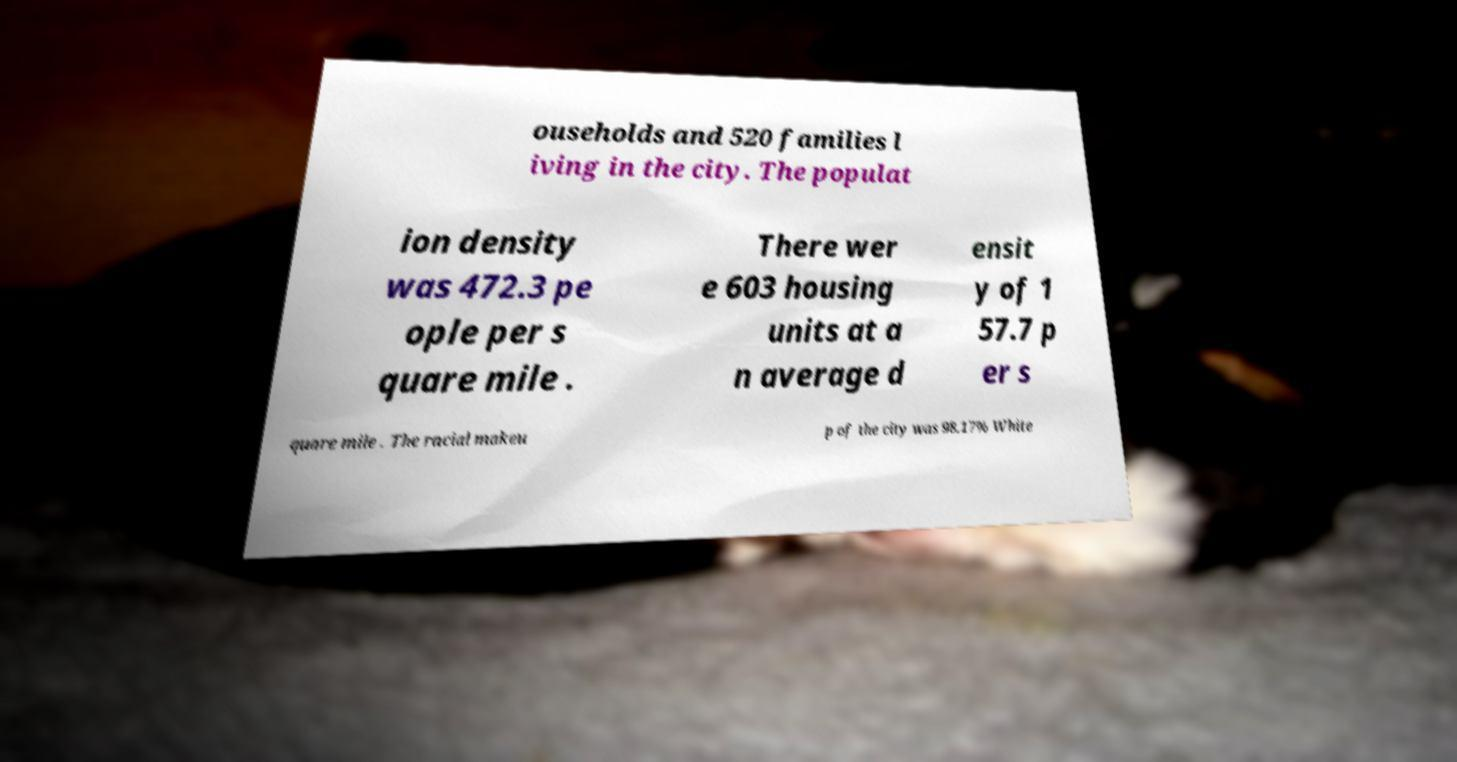There's text embedded in this image that I need extracted. Can you transcribe it verbatim? ouseholds and 520 families l iving in the city. The populat ion density was 472.3 pe ople per s quare mile . There wer e 603 housing units at a n average d ensit y of 1 57.7 p er s quare mile . The racial makeu p of the city was 98.17% White 